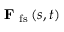Convert formula to latex. <formula><loc_0><loc_0><loc_500><loc_500>F _ { f s } \left ( s , t \right )</formula> 